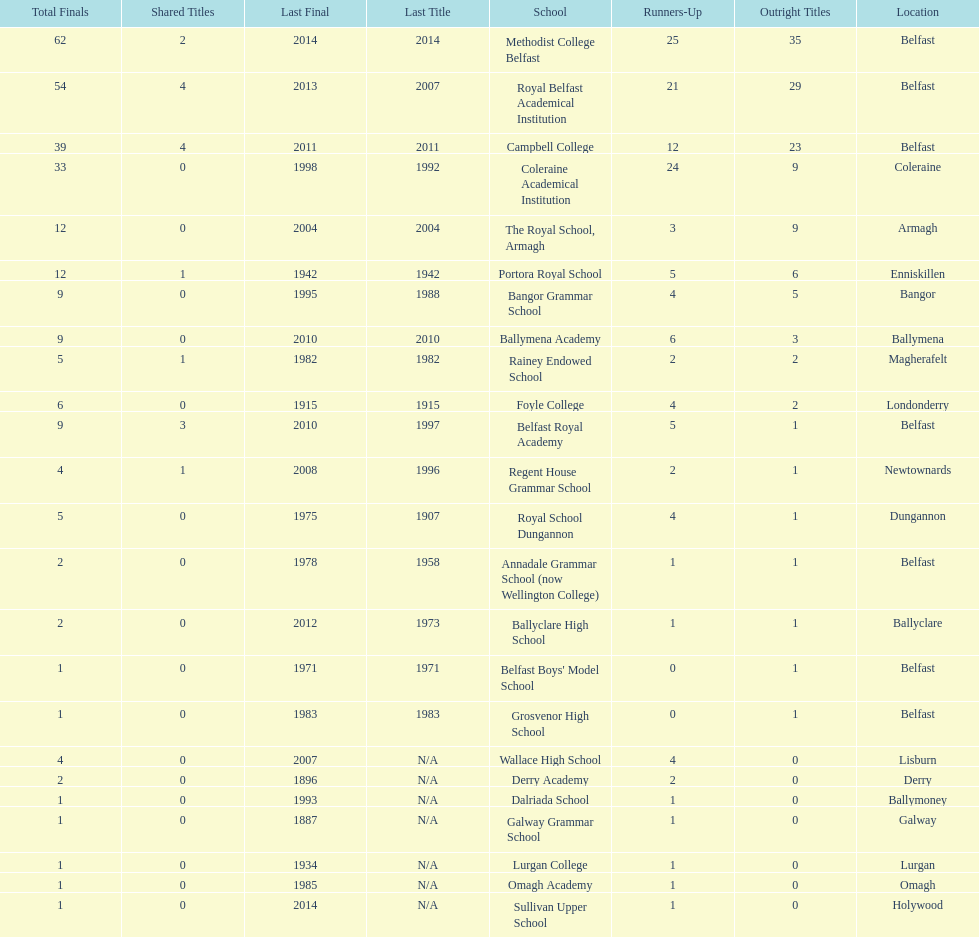What is the number of schools that hold a minimum of 5 undisputed championships? 7. 